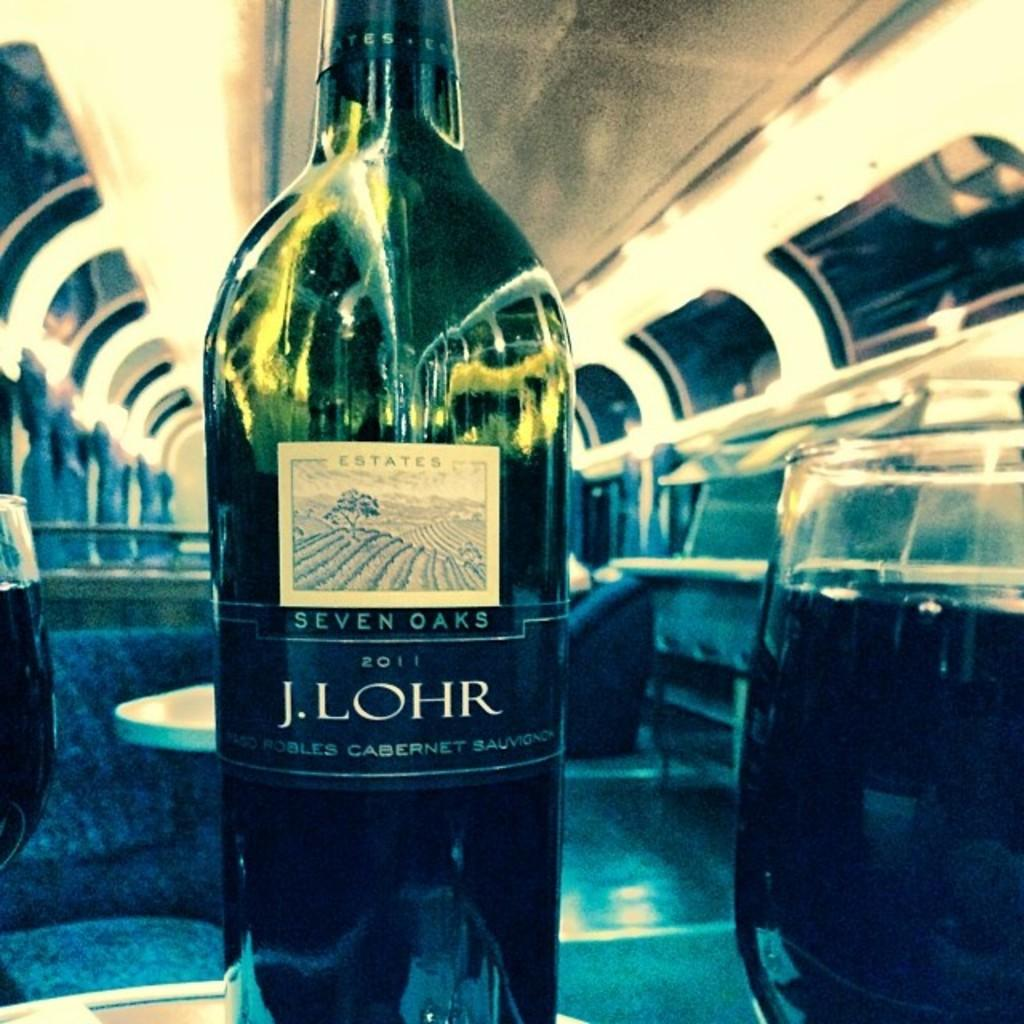Provide a one-sentence caption for the provided image. A bottle of Seven Oaks Cabernet Sauvignon 2011 is displayed in an exmpty train car. 